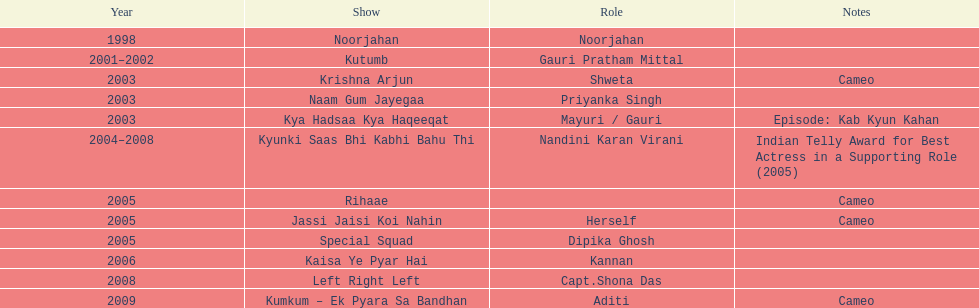In relation to "left right left," where is the show situated above it? Kaisa Ye Pyar Hai. 